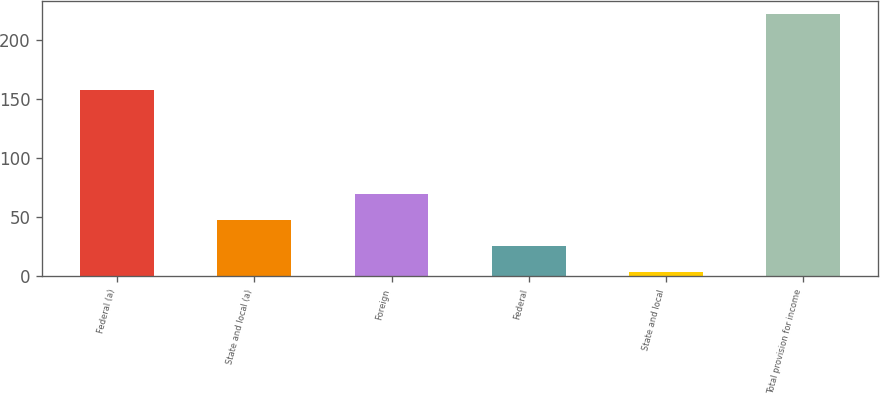Convert chart to OTSL. <chart><loc_0><loc_0><loc_500><loc_500><bar_chart><fcel>Federal (a)<fcel>State and local (a)<fcel>Foreign<fcel>Federal<fcel>State and local<fcel>Total provision for income<nl><fcel>157.5<fcel>47.58<fcel>69.42<fcel>25.74<fcel>3.9<fcel>222.3<nl></chart> 